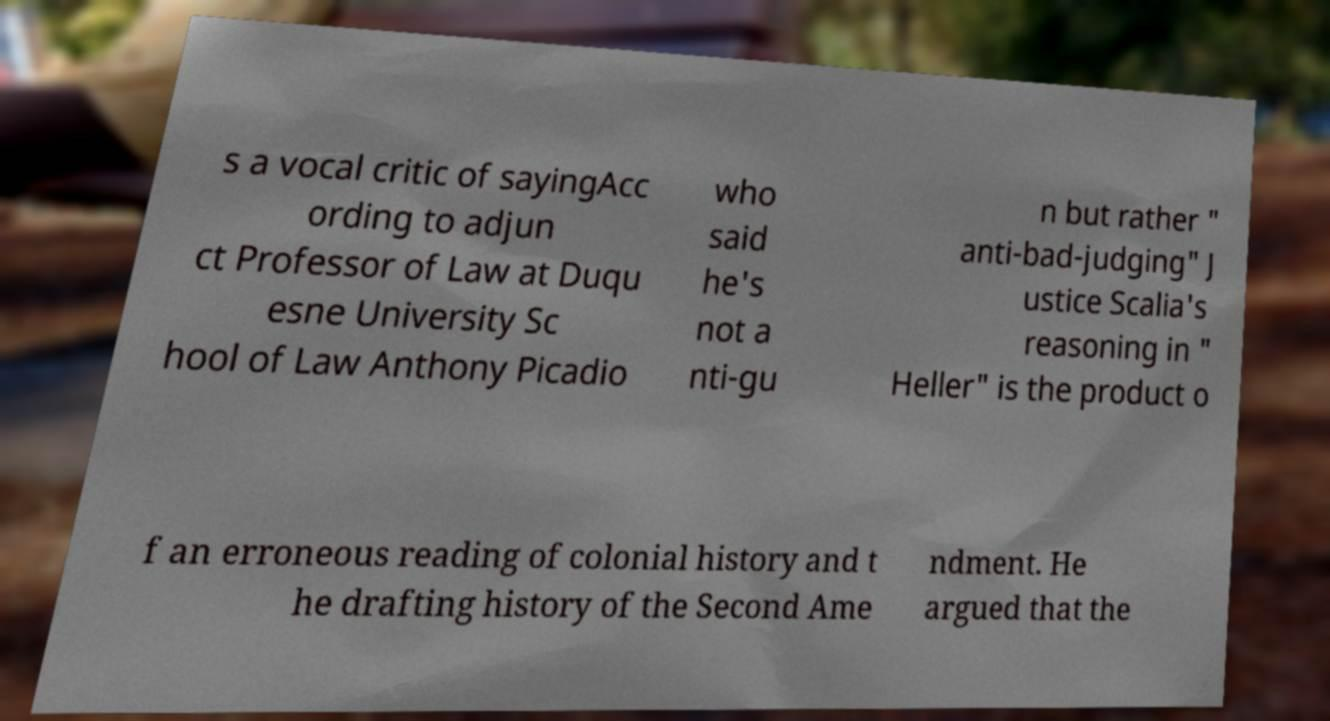Please read and relay the text visible in this image. What does it say? s a vocal critic of sayingAcc ording to adjun ct Professor of Law at Duqu esne University Sc hool of Law Anthony Picadio who said he's not a nti-gu n but rather " anti-bad-judging" J ustice Scalia's reasoning in " Heller" is the product o f an erroneous reading of colonial history and t he drafting history of the Second Ame ndment. He argued that the 